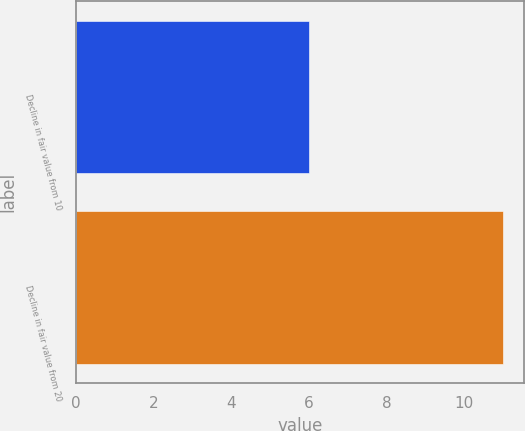<chart> <loc_0><loc_0><loc_500><loc_500><bar_chart><fcel>Decline in fair value from 10<fcel>Decline in fair value from 20<nl><fcel>6<fcel>11<nl></chart> 